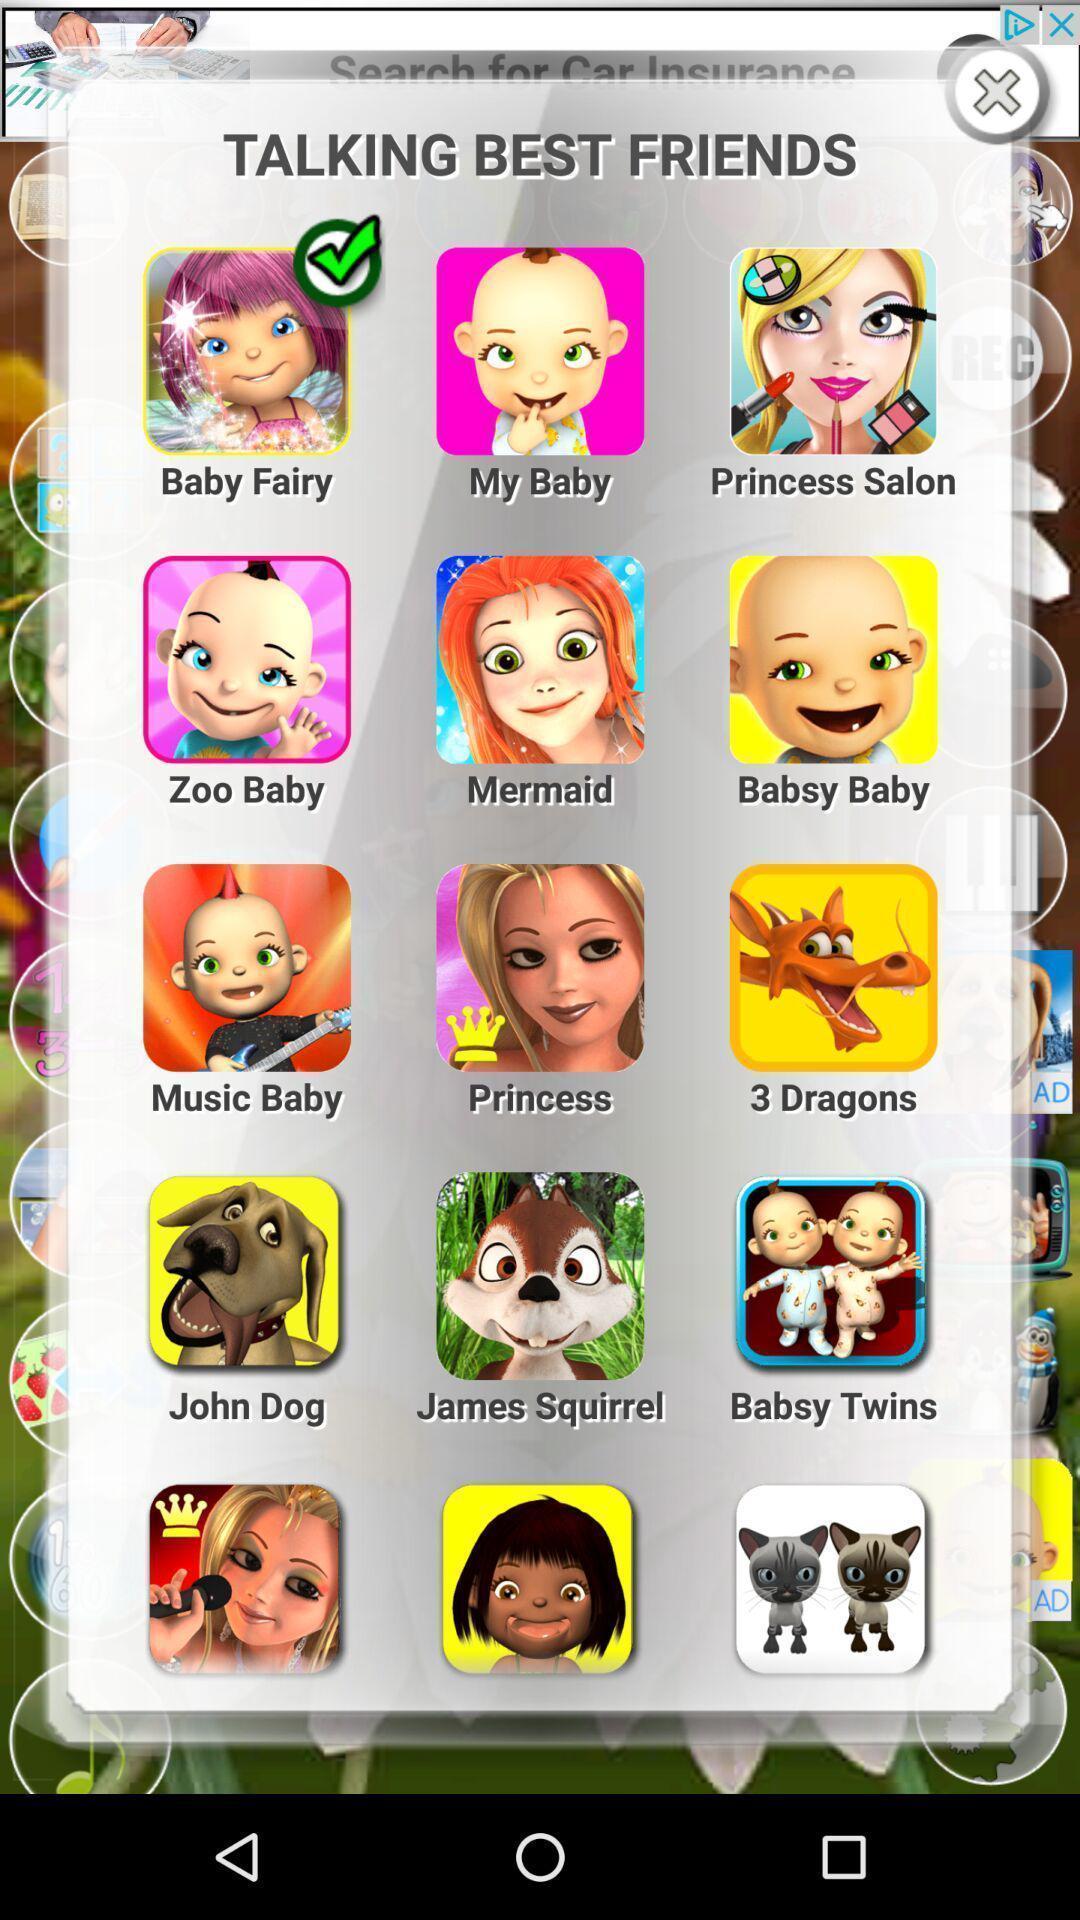Summarize the information in this screenshot. Pop-up displaying the list of talking app names. 